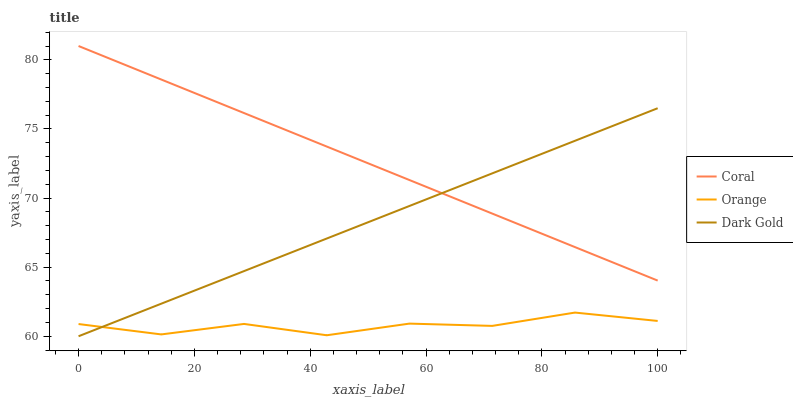Does Orange have the minimum area under the curve?
Answer yes or no. Yes. Does Coral have the maximum area under the curve?
Answer yes or no. Yes. Does Dark Gold have the minimum area under the curve?
Answer yes or no. No. Does Dark Gold have the maximum area under the curve?
Answer yes or no. No. Is Dark Gold the smoothest?
Answer yes or no. Yes. Is Orange the roughest?
Answer yes or no. Yes. Is Coral the smoothest?
Answer yes or no. No. Is Coral the roughest?
Answer yes or no. No. Does Dark Gold have the lowest value?
Answer yes or no. Yes. Does Coral have the lowest value?
Answer yes or no. No. Does Coral have the highest value?
Answer yes or no. Yes. Does Dark Gold have the highest value?
Answer yes or no. No. Is Orange less than Coral?
Answer yes or no. Yes. Is Coral greater than Orange?
Answer yes or no. Yes. Does Coral intersect Dark Gold?
Answer yes or no. Yes. Is Coral less than Dark Gold?
Answer yes or no. No. Is Coral greater than Dark Gold?
Answer yes or no. No. Does Orange intersect Coral?
Answer yes or no. No. 